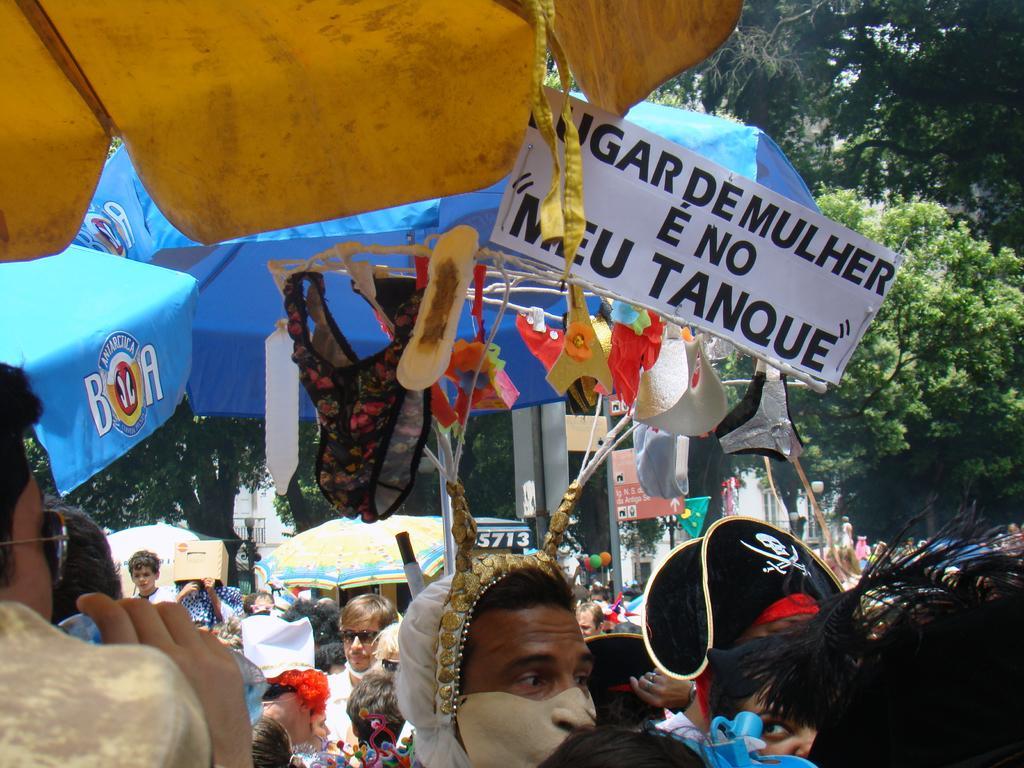How would you summarize this image in a sentence or two? In this picture we can see a group of people, umbrellas, name boards, flag, balloons and some objects and in the background we can see trees. 